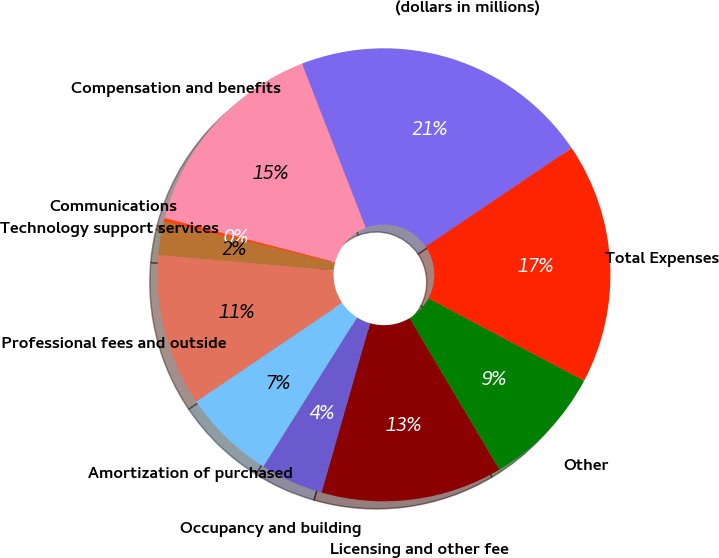Convert chart. <chart><loc_0><loc_0><loc_500><loc_500><pie_chart><fcel>(dollars in millions)<fcel>Compensation and benefits<fcel>Communications<fcel>Technology support services<fcel>Professional fees and outside<fcel>Amortization of purchased<fcel>Occupancy and building<fcel>Licensing and other fee<fcel>Other<fcel>Total Expenses<nl><fcel>21.44%<fcel>15.08%<fcel>0.26%<fcel>2.38%<fcel>10.85%<fcel>6.61%<fcel>4.49%<fcel>12.96%<fcel>8.73%<fcel>17.2%<nl></chart> 